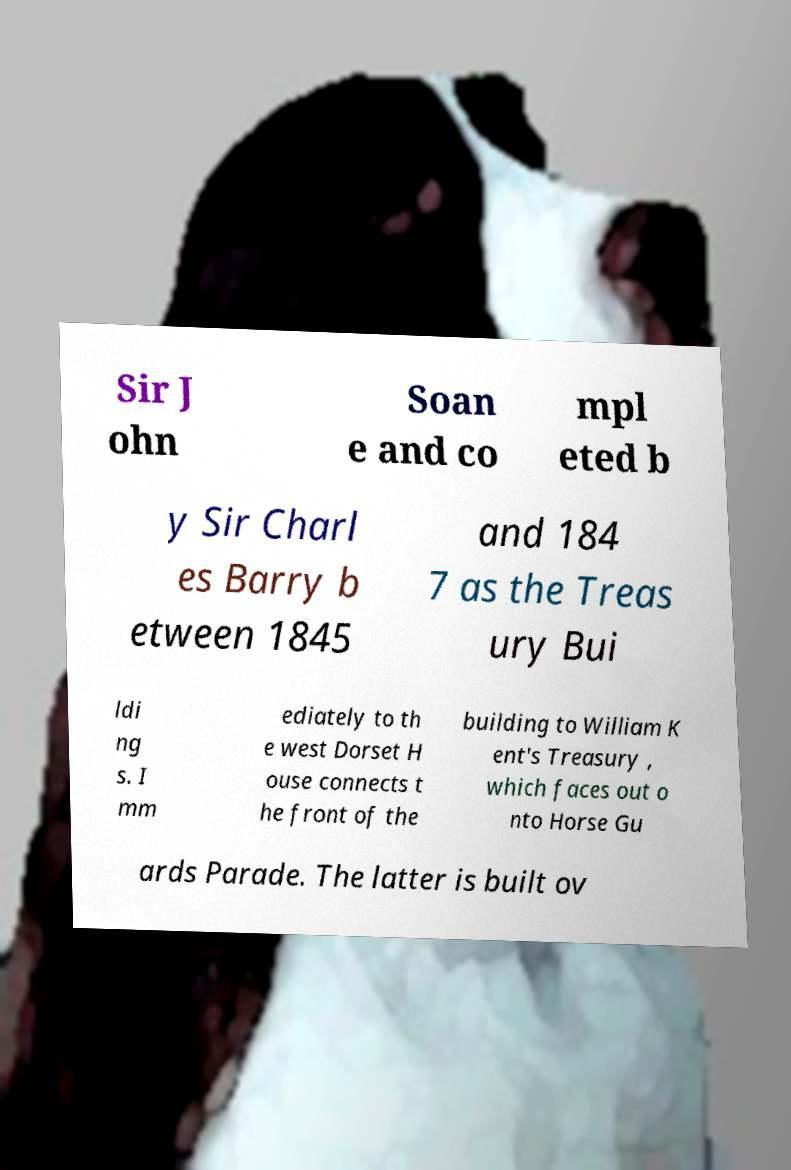What messages or text are displayed in this image? I need them in a readable, typed format. Sir J ohn Soan e and co mpl eted b y Sir Charl es Barry b etween 1845 and 184 7 as the Treas ury Bui ldi ng s. I mm ediately to th e west Dorset H ouse connects t he front of the building to William K ent's Treasury , which faces out o nto Horse Gu ards Parade. The latter is built ov 